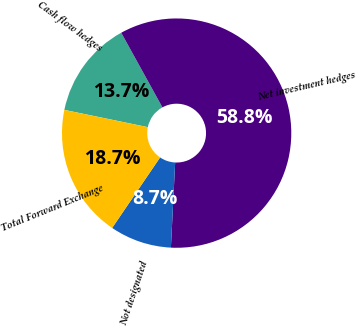Convert chart. <chart><loc_0><loc_0><loc_500><loc_500><pie_chart><fcel>Cash flow hedges<fcel>Net investment hedges<fcel>Not designated<fcel>Total Forward Exchange<nl><fcel>13.73%<fcel>58.82%<fcel>8.71%<fcel>18.74%<nl></chart> 